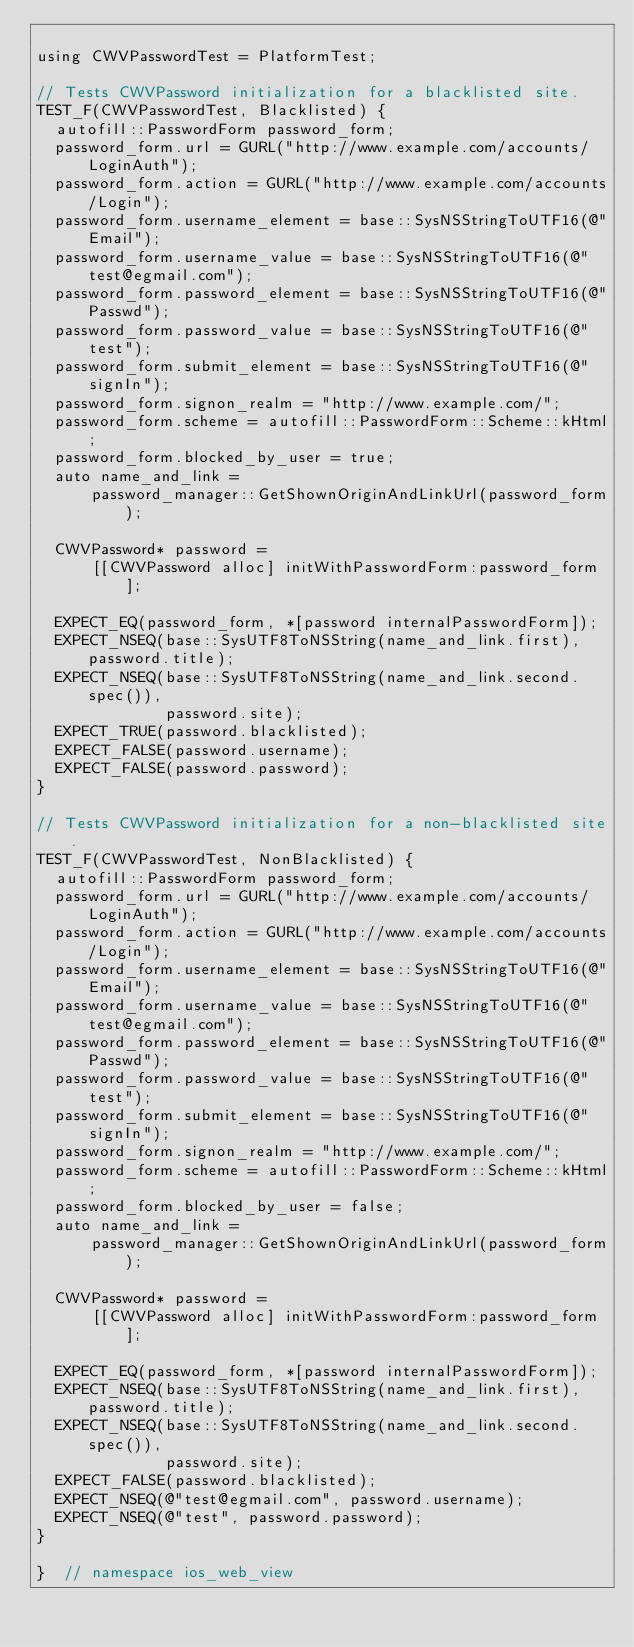<code> <loc_0><loc_0><loc_500><loc_500><_ObjectiveC_>
using CWVPasswordTest = PlatformTest;

// Tests CWVPassword initialization for a blacklisted site.
TEST_F(CWVPasswordTest, Blacklisted) {
  autofill::PasswordForm password_form;
  password_form.url = GURL("http://www.example.com/accounts/LoginAuth");
  password_form.action = GURL("http://www.example.com/accounts/Login");
  password_form.username_element = base::SysNSStringToUTF16(@"Email");
  password_form.username_value = base::SysNSStringToUTF16(@"test@egmail.com");
  password_form.password_element = base::SysNSStringToUTF16(@"Passwd");
  password_form.password_value = base::SysNSStringToUTF16(@"test");
  password_form.submit_element = base::SysNSStringToUTF16(@"signIn");
  password_form.signon_realm = "http://www.example.com/";
  password_form.scheme = autofill::PasswordForm::Scheme::kHtml;
  password_form.blocked_by_user = true;
  auto name_and_link =
      password_manager::GetShownOriginAndLinkUrl(password_form);

  CWVPassword* password =
      [[CWVPassword alloc] initWithPasswordForm:password_form];

  EXPECT_EQ(password_form, *[password internalPasswordForm]);
  EXPECT_NSEQ(base::SysUTF8ToNSString(name_and_link.first), password.title);
  EXPECT_NSEQ(base::SysUTF8ToNSString(name_and_link.second.spec()),
              password.site);
  EXPECT_TRUE(password.blacklisted);
  EXPECT_FALSE(password.username);
  EXPECT_FALSE(password.password);
}

// Tests CWVPassword initialization for a non-blacklisted site.
TEST_F(CWVPasswordTest, NonBlacklisted) {
  autofill::PasswordForm password_form;
  password_form.url = GURL("http://www.example.com/accounts/LoginAuth");
  password_form.action = GURL("http://www.example.com/accounts/Login");
  password_form.username_element = base::SysNSStringToUTF16(@"Email");
  password_form.username_value = base::SysNSStringToUTF16(@"test@egmail.com");
  password_form.password_element = base::SysNSStringToUTF16(@"Passwd");
  password_form.password_value = base::SysNSStringToUTF16(@"test");
  password_form.submit_element = base::SysNSStringToUTF16(@"signIn");
  password_form.signon_realm = "http://www.example.com/";
  password_form.scheme = autofill::PasswordForm::Scheme::kHtml;
  password_form.blocked_by_user = false;
  auto name_and_link =
      password_manager::GetShownOriginAndLinkUrl(password_form);

  CWVPassword* password =
      [[CWVPassword alloc] initWithPasswordForm:password_form];

  EXPECT_EQ(password_form, *[password internalPasswordForm]);
  EXPECT_NSEQ(base::SysUTF8ToNSString(name_and_link.first), password.title);
  EXPECT_NSEQ(base::SysUTF8ToNSString(name_and_link.second.spec()),
              password.site);
  EXPECT_FALSE(password.blacklisted);
  EXPECT_NSEQ(@"test@egmail.com", password.username);
  EXPECT_NSEQ(@"test", password.password);
}

}  // namespace ios_web_view
</code> 